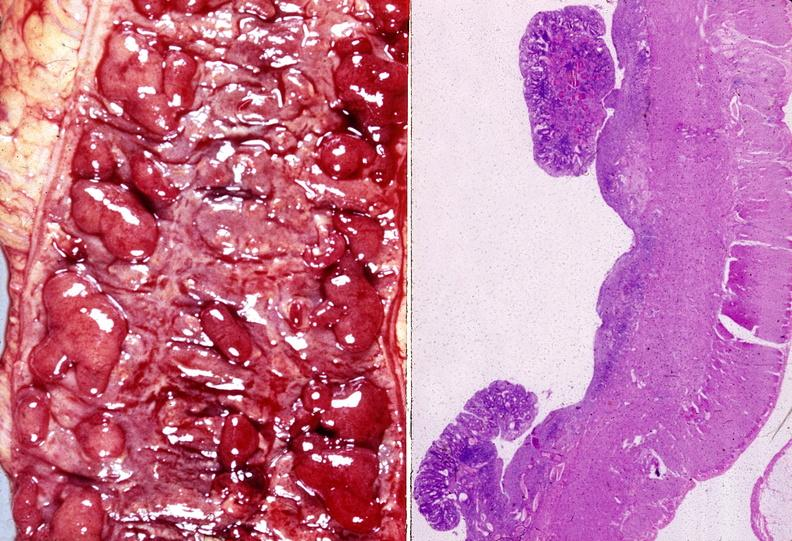what is present?
Answer the question using a single word or phrase. Gastrointestinal 